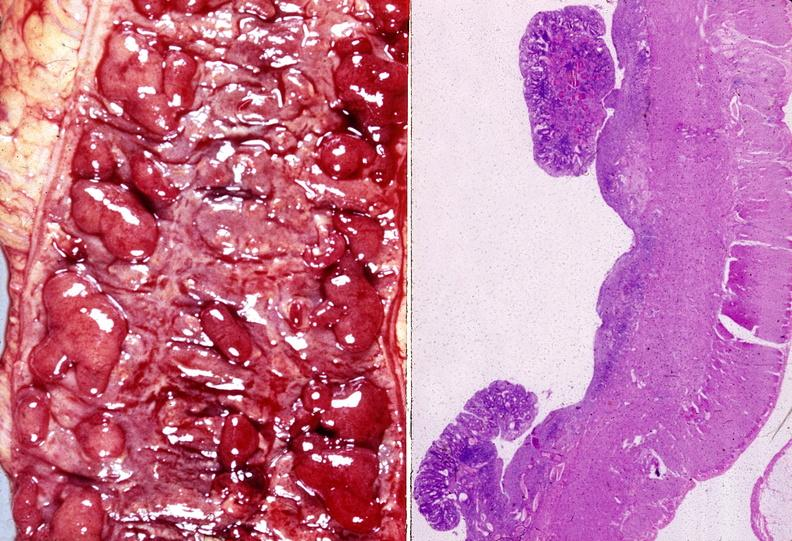what is present?
Answer the question using a single word or phrase. Gastrointestinal 